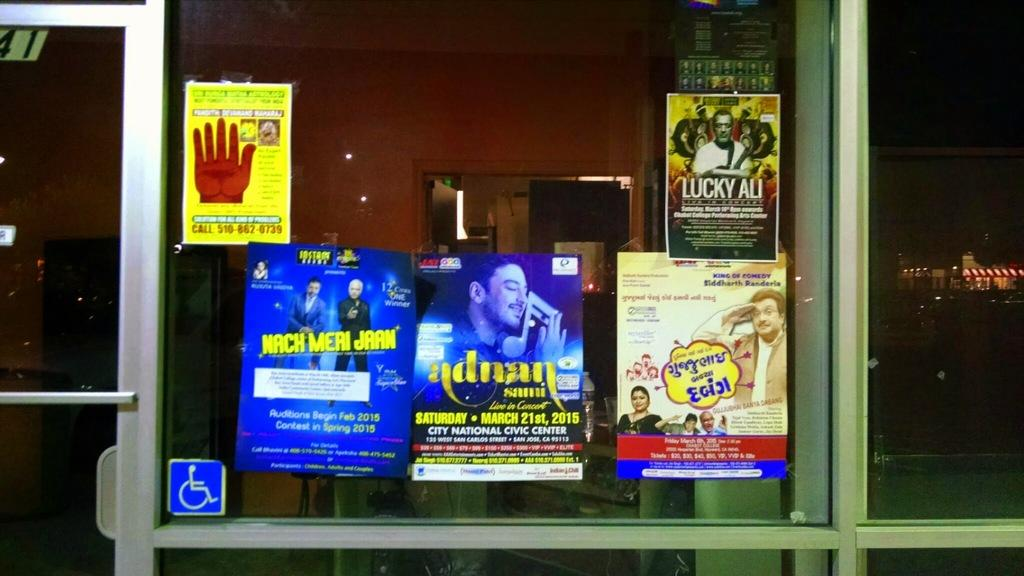Provide a one-sentence caption for the provided image. A store front has several musical posters including one for adnan. 